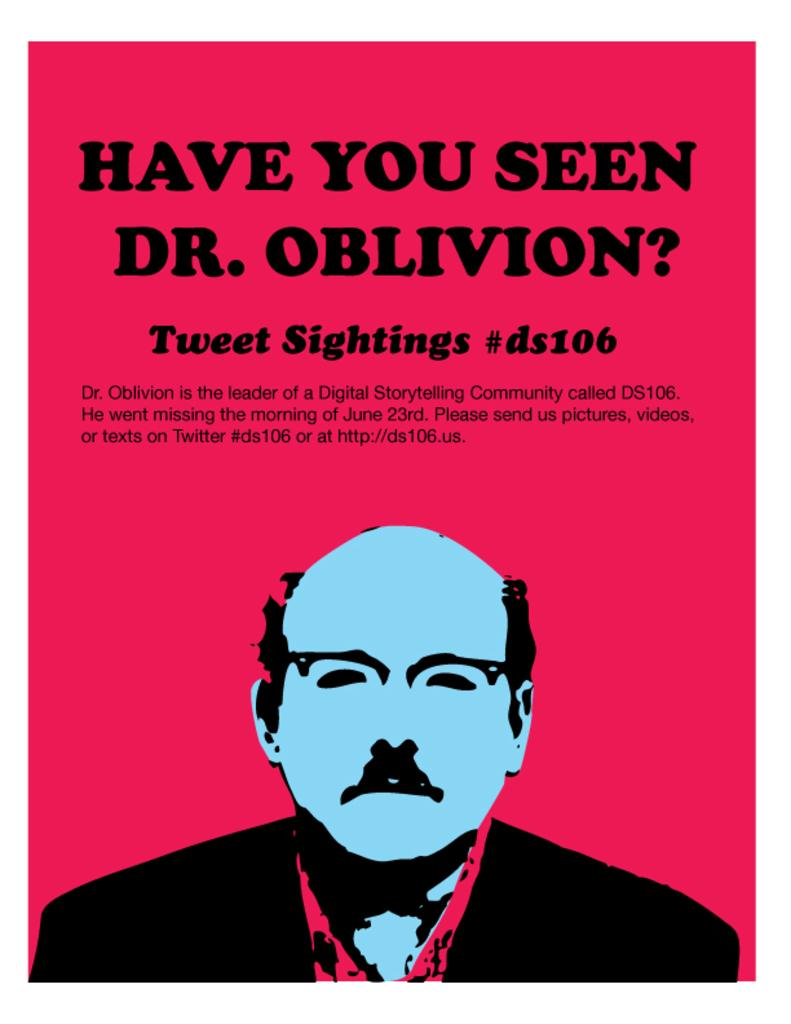<image>
Provide a brief description of the given image. A red poster asking "Have you seen Dr. Obilvion" 